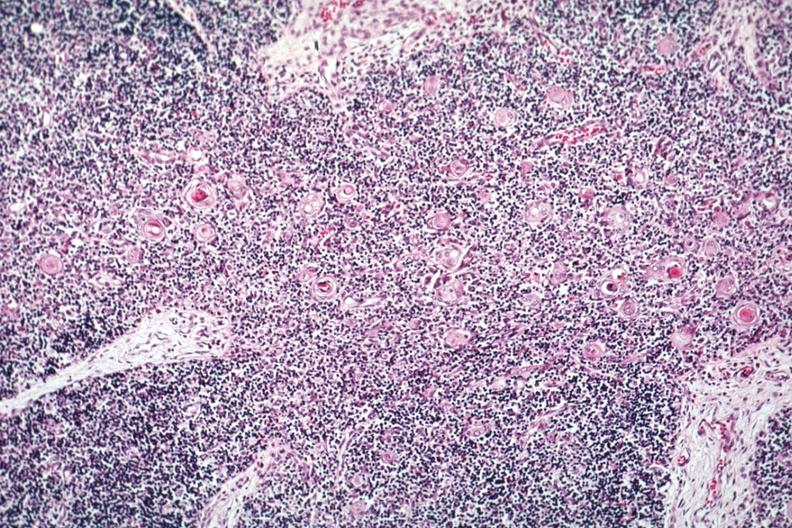s vasculature present?
Answer the question using a single word or phrase. No 